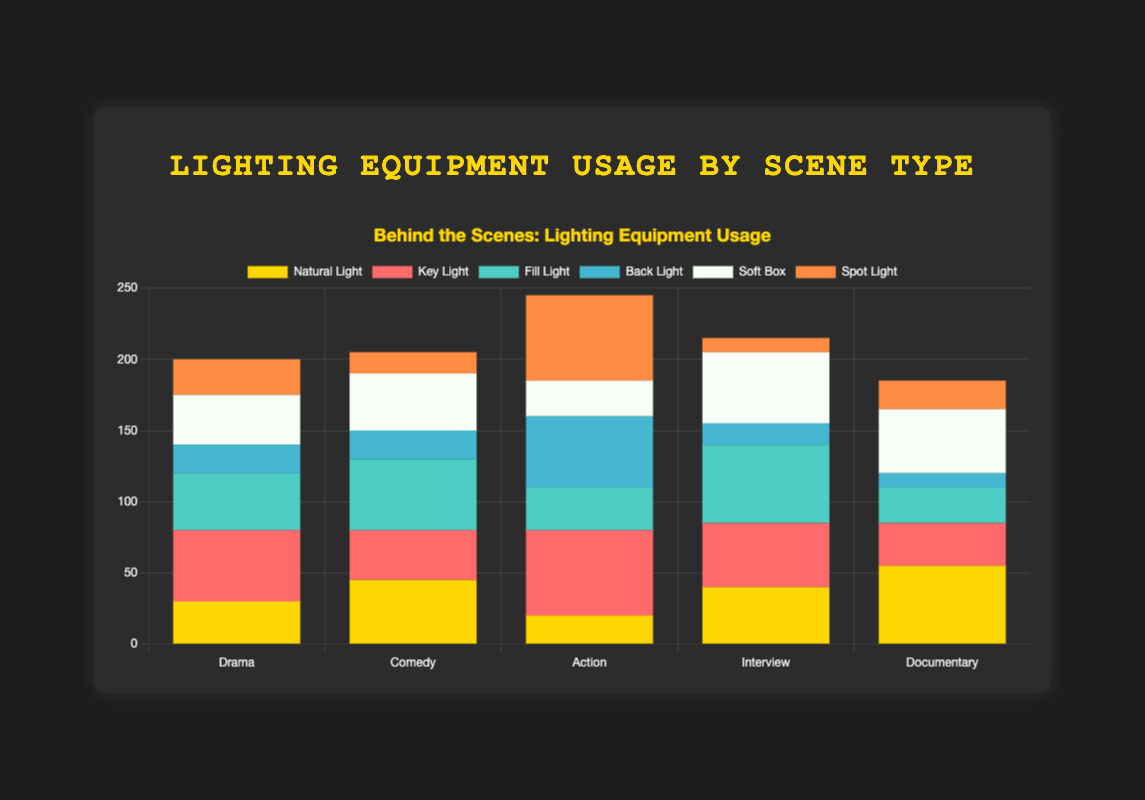Which scene type uses the most Natural Light? The bar for Natural Light in the Documentary scene type is the tallest compared to other scene types.
Answer: Documentary Which lighting type is used the least in Comedy scenes? By comparing the bar heights on the Comedy bar stack, the Spot Light bar is the shortest.
Answer: Spot Light How many types of lighting equipment are used more than 30 times in Interview scenes? Count the bars that exceed a height corresponding to 30 units. They are Natural Light, Key Light, Fill Light, and Soft Box.
Answer: 4 Does Drama or Action use more Back Light, and by how much? Drama uses 20 units of Back Light while Action uses 50 units. The difference is 50 - 20 = 30 units.
Answer: Action, by 30 units Which scene type shows Fill Light as the most used lighting type? The tallest bar for Fill Light can be compared across all scene types, which is the Interview scene.
Answer: Interview In which scene type is the relative usage of Soft Box nearly equal to Natural Light, and how can you tell? For both Soft Box and Natural Light, Documentary scene types show bars that are roughly the same height visually.
Answer: Documentary What is the sum of all lighting equipment used in Action scenes? Add up all values in the Action scene type: 20 (Natural Light) + 60 (Key Light) + 30 (Fill Light) + 50 (Back Light) + 25 (Soft Box) + 60 (Spot Light) = 245.
Answer: 245 Compare the total usage of Key Light in Drama and Comedy scenes; which is higher? Key Light in Drama is 50 and in Comedy is 35, so Drama uses more by 50 - 35 = 15 units.
Answer: Drama How does the usage of Spot Light in Action scenes compare to its usage in Interview scenes? Action has 60 units of Spot Light whereas Interview has 10 units. So, Action uses more by 60 - 10 = 50 units.
Answer: Action, by 50 units Which lighting type is consistently used in all scene types? By observing the figure, every scene type has bars for each lighting type, showing all lighting types are used in every scene type.
Answer: All lighting types 